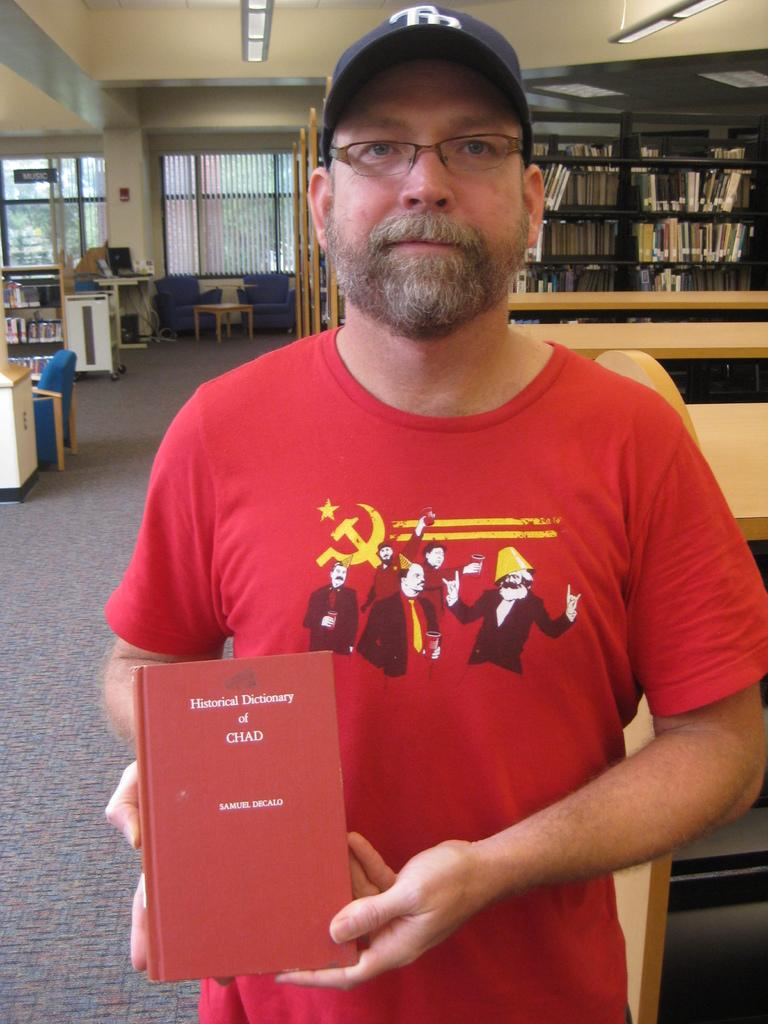Provide a one-sentence caption for the provided image. A man wearing a red shirt, is holding Samuel Decalo's Historical Dictonary of Chat. 